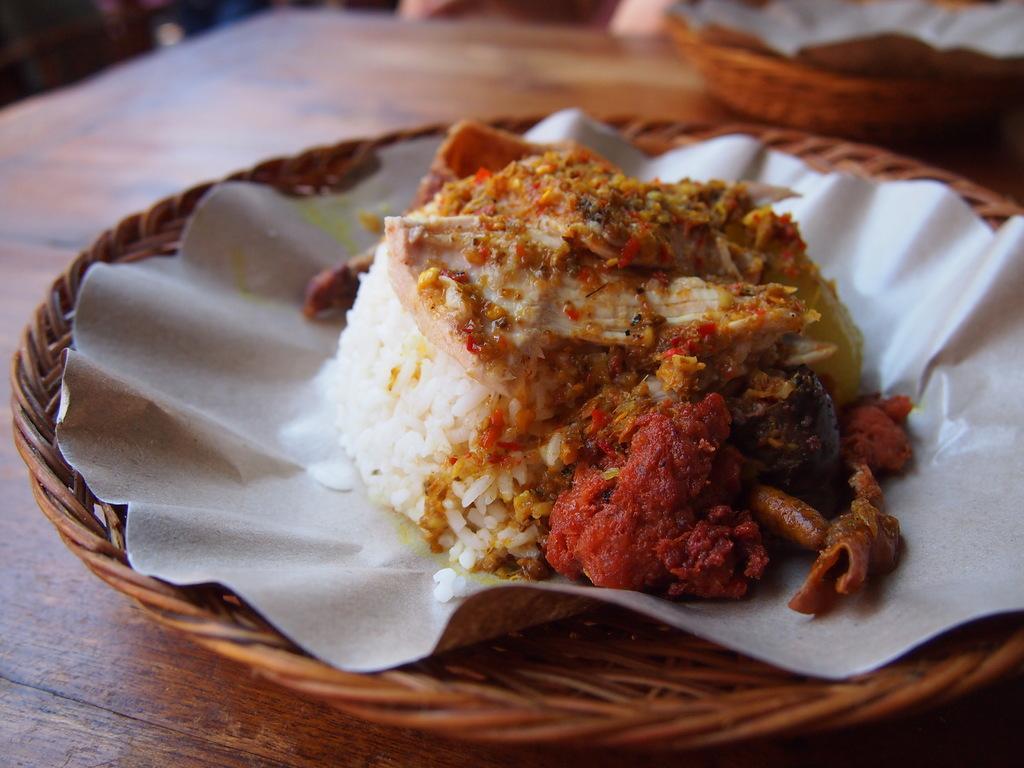Describe this image in one or two sentences. In this image there is a table, on that table there is a wooden bowl, in that there is a food item. 